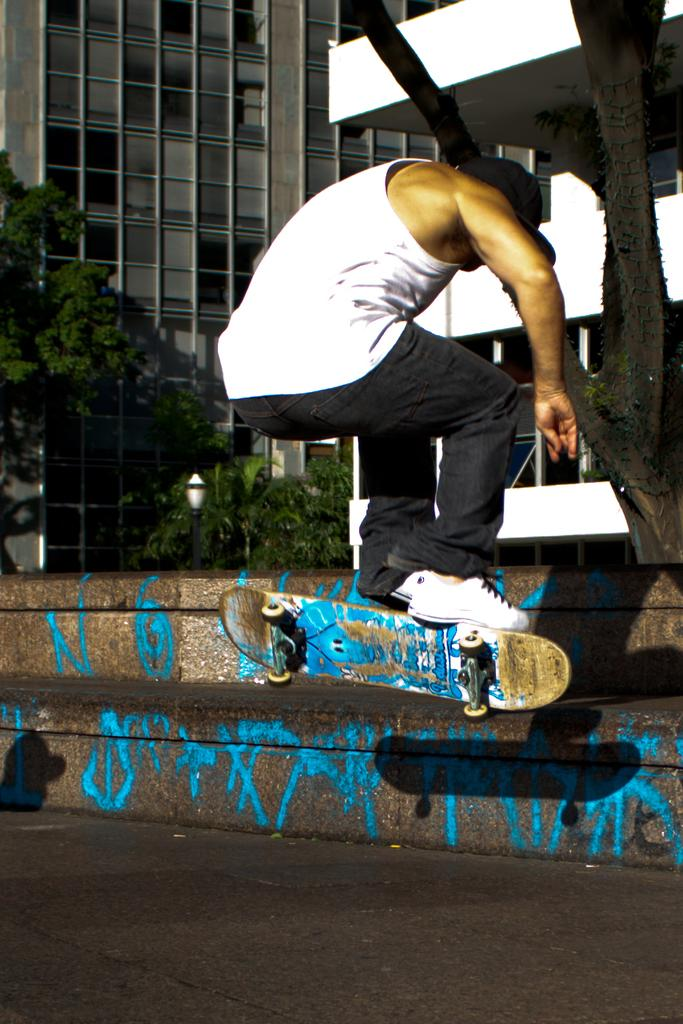What is the person in the image doing? There is a person on a skateboard in the image. What is the setting of the image? There is a road in the image. Are there any architectural features present? Yes, there are steps in the image. What can be seen in the background of the image? There are trees and buildings in the background of the image. What type of observation can be made about the road in the image? There is no specific observation about the road mentioned in the facts, so it is not possible to answer that question. 